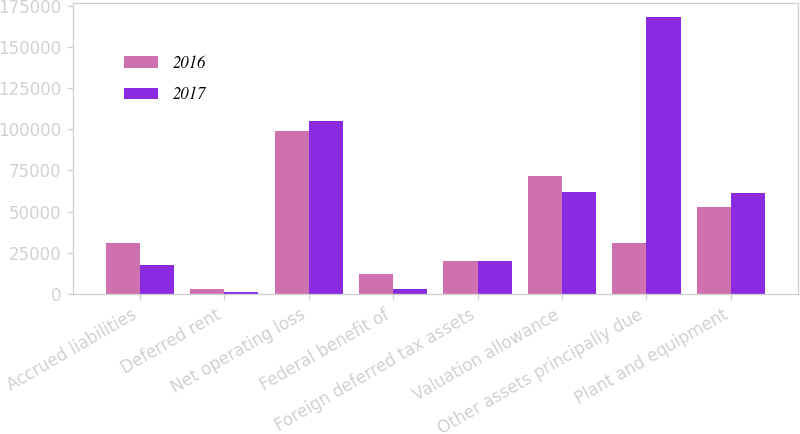Convert chart. <chart><loc_0><loc_0><loc_500><loc_500><stacked_bar_chart><ecel><fcel>Accrued liabilities<fcel>Deferred rent<fcel>Net operating loss<fcel>Federal benefit of<fcel>Foreign deferred tax assets<fcel>Valuation allowance<fcel>Other assets principally due<fcel>Plant and equipment<nl><fcel>2016<fcel>30901<fcel>2930<fcel>98879<fcel>12036<fcel>20131<fcel>71359<fcel>30901<fcel>52572<nl><fcel>2017<fcel>17565<fcel>1337<fcel>105026<fcel>3051<fcel>20029<fcel>61756<fcel>168028<fcel>61530<nl></chart> 